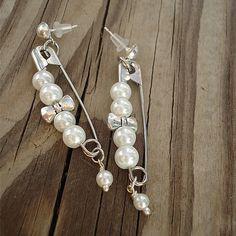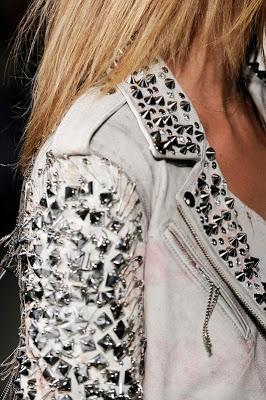The first image is the image on the left, the second image is the image on the right. Analyze the images presented: Is the assertion "An image features a jacket with an embellished studded lapel." valid? Answer yes or no. Yes. The first image is the image on the left, the second image is the image on the right. Considering the images on both sides, is "The jewelry in the image on the right is made from safety pins" valid? Answer yes or no. No. 